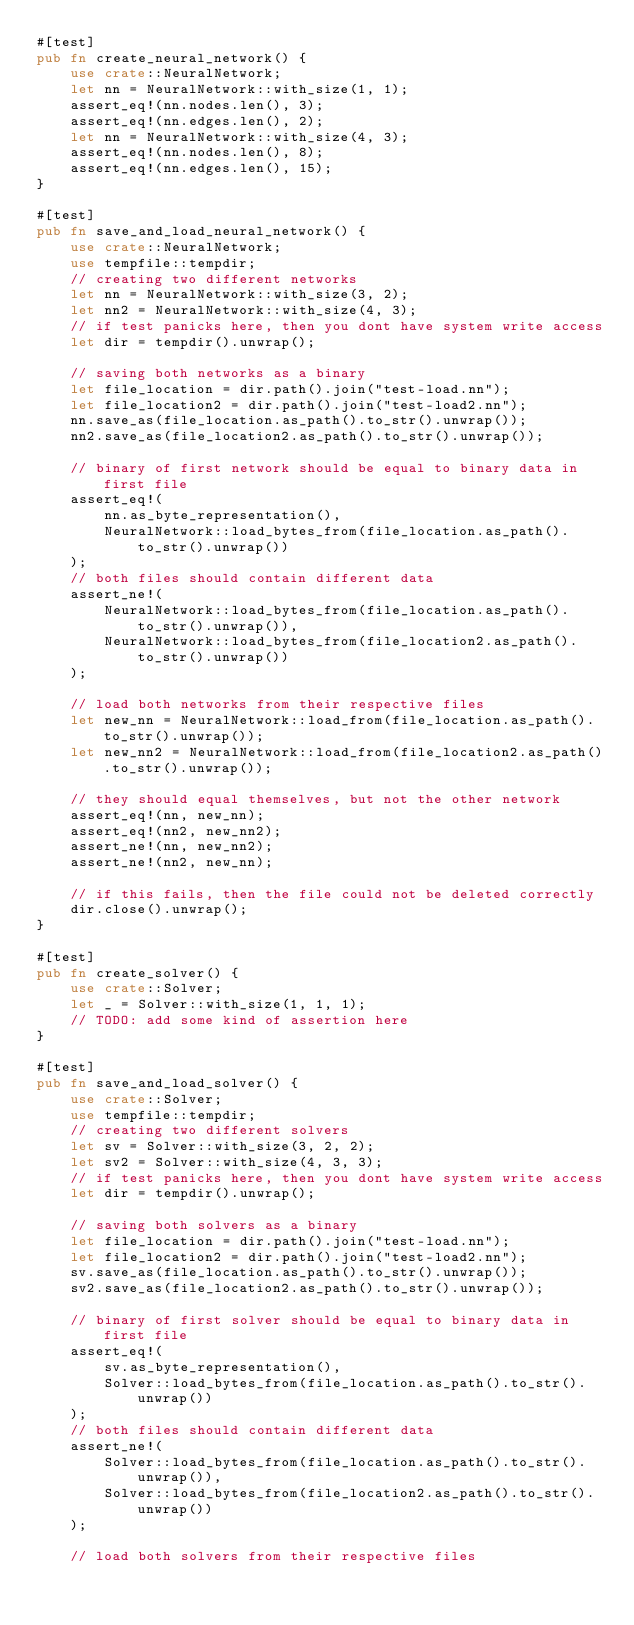Convert code to text. <code><loc_0><loc_0><loc_500><loc_500><_Rust_>#[test]
pub fn create_neural_network() {
    use crate::NeuralNetwork;
    let nn = NeuralNetwork::with_size(1, 1);
    assert_eq!(nn.nodes.len(), 3);
    assert_eq!(nn.edges.len(), 2);
    let nn = NeuralNetwork::with_size(4, 3);
    assert_eq!(nn.nodes.len(), 8);
    assert_eq!(nn.edges.len(), 15);
}

#[test]
pub fn save_and_load_neural_network() {
    use crate::NeuralNetwork;
    use tempfile::tempdir;
    // creating two different networks
    let nn = NeuralNetwork::with_size(3, 2);
    let nn2 = NeuralNetwork::with_size(4, 3);
    // if test panicks here, then you dont have system write access
    let dir = tempdir().unwrap();

    // saving both networks as a binary
    let file_location = dir.path().join("test-load.nn");
    let file_location2 = dir.path().join("test-load2.nn");
    nn.save_as(file_location.as_path().to_str().unwrap());
    nn2.save_as(file_location2.as_path().to_str().unwrap());

    // binary of first network should be equal to binary data in first file
    assert_eq!(
        nn.as_byte_representation(),
        NeuralNetwork::load_bytes_from(file_location.as_path().to_str().unwrap())
    );
    // both files should contain different data
    assert_ne!(
        NeuralNetwork::load_bytes_from(file_location.as_path().to_str().unwrap()),
        NeuralNetwork::load_bytes_from(file_location2.as_path().to_str().unwrap())
    );

    // load both networks from their respective files
    let new_nn = NeuralNetwork::load_from(file_location.as_path().to_str().unwrap());
    let new_nn2 = NeuralNetwork::load_from(file_location2.as_path().to_str().unwrap());

    // they should equal themselves, but not the other network
    assert_eq!(nn, new_nn);
    assert_eq!(nn2, new_nn2);
    assert_ne!(nn, new_nn2);
    assert_ne!(nn2, new_nn);

    // if this fails, then the file could not be deleted correctly
    dir.close().unwrap();
}

#[test]
pub fn create_solver() {
    use crate::Solver;
    let _ = Solver::with_size(1, 1, 1);
    // TODO: add some kind of assertion here
}

#[test]
pub fn save_and_load_solver() {
    use crate::Solver;
    use tempfile::tempdir;
    // creating two different solvers
    let sv = Solver::with_size(3, 2, 2);
    let sv2 = Solver::with_size(4, 3, 3);
    // if test panicks here, then you dont have system write access
    let dir = tempdir().unwrap();

    // saving both solvers as a binary
    let file_location = dir.path().join("test-load.nn");
    let file_location2 = dir.path().join("test-load2.nn");
    sv.save_as(file_location.as_path().to_str().unwrap());
    sv2.save_as(file_location2.as_path().to_str().unwrap());

    // binary of first solver should be equal to binary data in first file
    assert_eq!(
        sv.as_byte_representation(),
        Solver::load_bytes_from(file_location.as_path().to_str().unwrap())
    );
    // both files should contain different data
    assert_ne!(
        Solver::load_bytes_from(file_location.as_path().to_str().unwrap()),
        Solver::load_bytes_from(file_location2.as_path().to_str().unwrap())
    );

    // load both solvers from their respective files</code> 